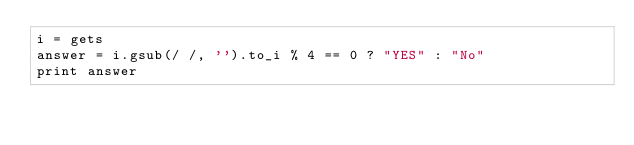<code> <loc_0><loc_0><loc_500><loc_500><_Ruby_>i = gets
answer = i.gsub(/ /, '').to_i % 4 == 0 ? "YES" : "No"
print answer</code> 